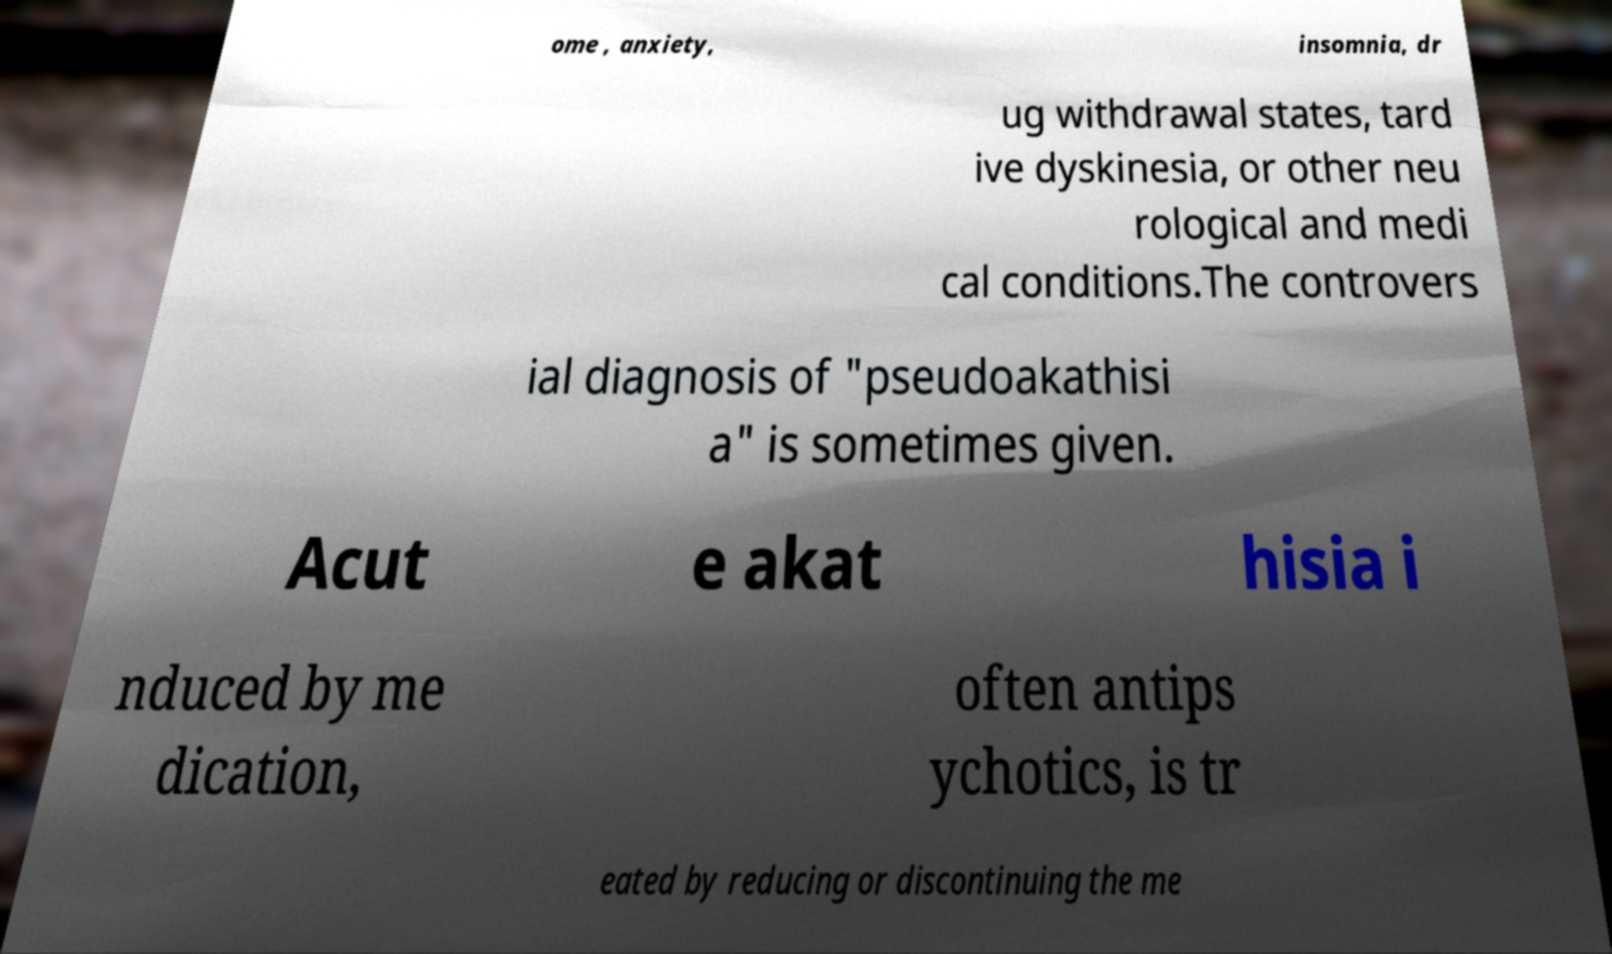What messages or text are displayed in this image? I need them in a readable, typed format. ome , anxiety, insomnia, dr ug withdrawal states, tard ive dyskinesia, or other neu rological and medi cal conditions.The controvers ial diagnosis of "pseudoakathisi a" is sometimes given. Acut e akat hisia i nduced by me dication, often antips ychotics, is tr eated by reducing or discontinuing the me 